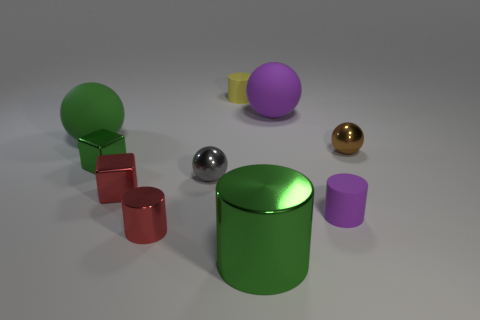There is a tiny object that is the same color as the small metal cylinder; what is it made of?
Provide a short and direct response. Metal. How many tiny purple matte objects are right of the cylinder that is to the right of the big purple matte thing?
Make the answer very short. 0. There is another sphere that is the same material as the small gray ball; what is its color?
Your answer should be very brief. Brown. Is there a green metal ball of the same size as the purple rubber ball?
Offer a terse response. No. What shape is the yellow rubber thing that is the same size as the gray shiny sphere?
Your answer should be very brief. Cylinder. Is there a tiny purple object of the same shape as the large purple matte object?
Make the answer very short. No. Do the red cube and the large object that is in front of the brown thing have the same material?
Your response must be concise. Yes. Is there a tiny thing that has the same color as the large cylinder?
Offer a very short reply. Yes. How many other things are there of the same material as the gray object?
Offer a very short reply. 5. Does the big shiny cylinder have the same color as the sphere on the right side of the purple rubber cylinder?
Ensure brevity in your answer.  No. 